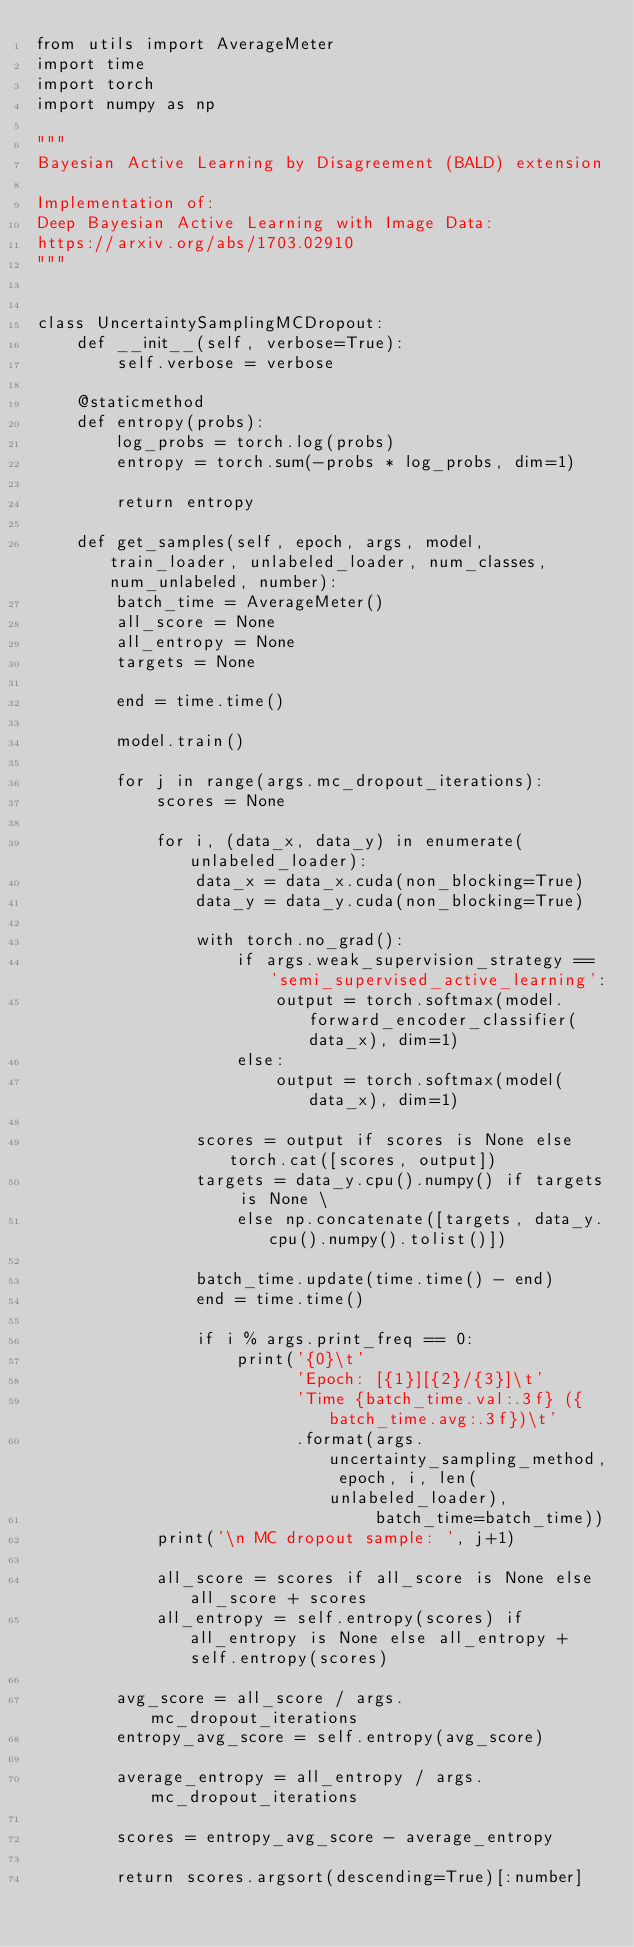<code> <loc_0><loc_0><loc_500><loc_500><_Python_>from utils import AverageMeter
import time
import torch
import numpy as np

"""
Bayesian Active Learning by Disagreement (BALD) extension

Implementation of:
Deep Bayesian Active Learning with Image Data:
https://arxiv.org/abs/1703.02910
"""


class UncertaintySamplingMCDropout:
    def __init__(self, verbose=True):
        self.verbose = verbose

    @staticmethod
    def entropy(probs):
        log_probs = torch.log(probs)
        entropy = torch.sum(-probs * log_probs, dim=1)

        return entropy

    def get_samples(self, epoch, args, model, train_loader, unlabeled_loader, num_classes, num_unlabeled, number):
        batch_time = AverageMeter()
        all_score = None
        all_entropy = None
        targets = None

        end = time.time()

        model.train()

        for j in range(args.mc_dropout_iterations):
            scores = None

            for i, (data_x, data_y) in enumerate(unlabeled_loader):
                data_x = data_x.cuda(non_blocking=True)
                data_y = data_y.cuda(non_blocking=True)

                with torch.no_grad():
                    if args.weak_supervision_strategy == 'semi_supervised_active_learning':
                        output = torch.softmax(model.forward_encoder_classifier(data_x), dim=1)
                    else:
                        output = torch.softmax(model(data_x), dim=1)

                scores = output if scores is None else torch.cat([scores, output])
                targets = data_y.cpu().numpy() if targets is None \
                    else np.concatenate([targets, data_y.cpu().numpy().tolist()])

                batch_time.update(time.time() - end)
                end = time.time()

                if i % args.print_freq == 0:
                    print('{0}\t'
                          'Epoch: [{1}][{2}/{3}]\t'
                          'Time {batch_time.val:.3f} ({batch_time.avg:.3f})\t'
                          .format(args.uncertainty_sampling_method, epoch, i, len(unlabeled_loader),
                                  batch_time=batch_time))
            print('\n MC dropout sample: ', j+1)

            all_score = scores if all_score is None else all_score + scores
            all_entropy = self.entropy(scores) if all_entropy is None else all_entropy + self.entropy(scores)

        avg_score = all_score / args.mc_dropout_iterations
        entropy_avg_score = self.entropy(avg_score)

        average_entropy = all_entropy / args.mc_dropout_iterations

        scores = entropy_avg_score - average_entropy

        return scores.argsort(descending=True)[:number]
</code> 